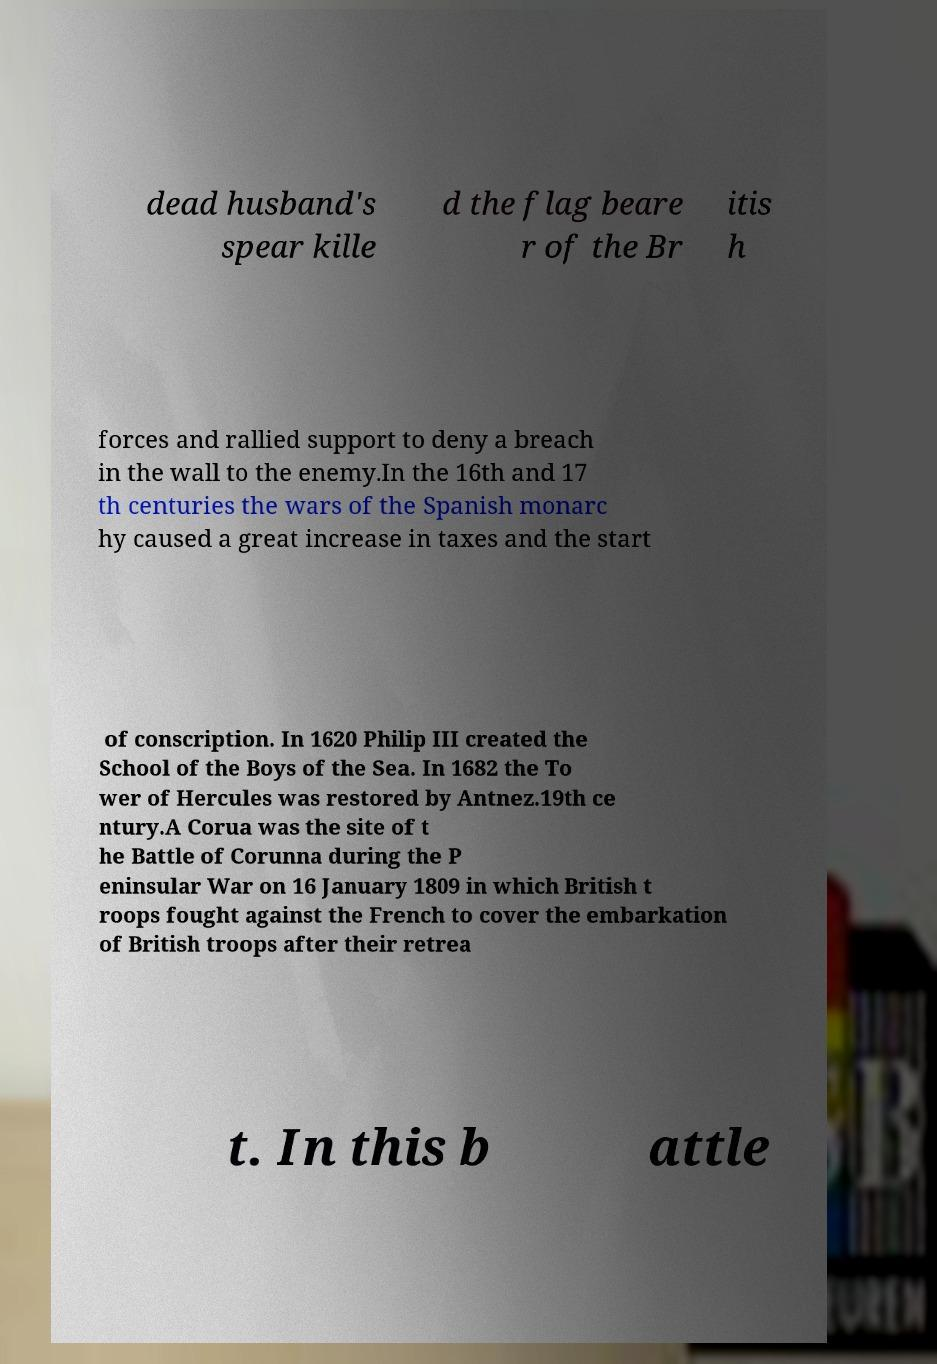What messages or text are displayed in this image? I need them in a readable, typed format. dead husband's spear kille d the flag beare r of the Br itis h forces and rallied support to deny a breach in the wall to the enemy.In the 16th and 17 th centuries the wars of the Spanish monarc hy caused a great increase in taxes and the start of conscription. In 1620 Philip III created the School of the Boys of the Sea. In 1682 the To wer of Hercules was restored by Antnez.19th ce ntury.A Corua was the site of t he Battle of Corunna during the P eninsular War on 16 January 1809 in which British t roops fought against the French to cover the embarkation of British troops after their retrea t. In this b attle 